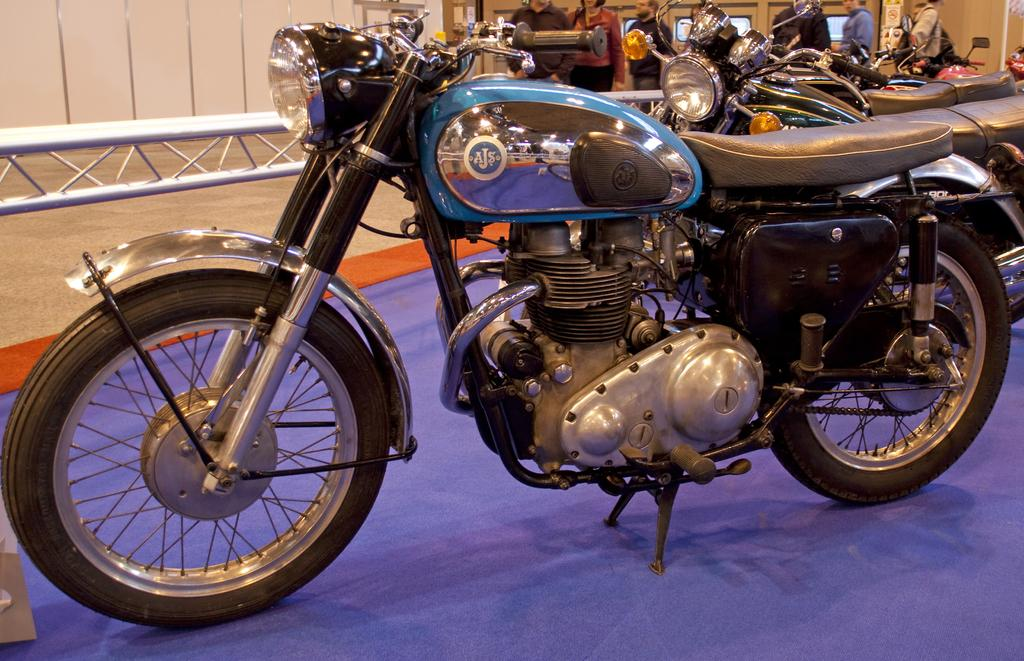What can be seen in the foreground of the picture? There are bikes in the foreground of the picture. What is located in the center of the picture? There are people in the center of the picture. What architectural features are visible in the background of the picture? There are doors and a wall in the background of the picture. Where is the map located in the picture? There is no map present in the image. What type of quiver can be seen on the wall in the background? There is no quiver present in the image; only doors and a wall are visible in the background. 